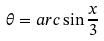Convert formula to latex. <formula><loc_0><loc_0><loc_500><loc_500>\theta = a r c \sin \frac { x } { 3 }</formula> 